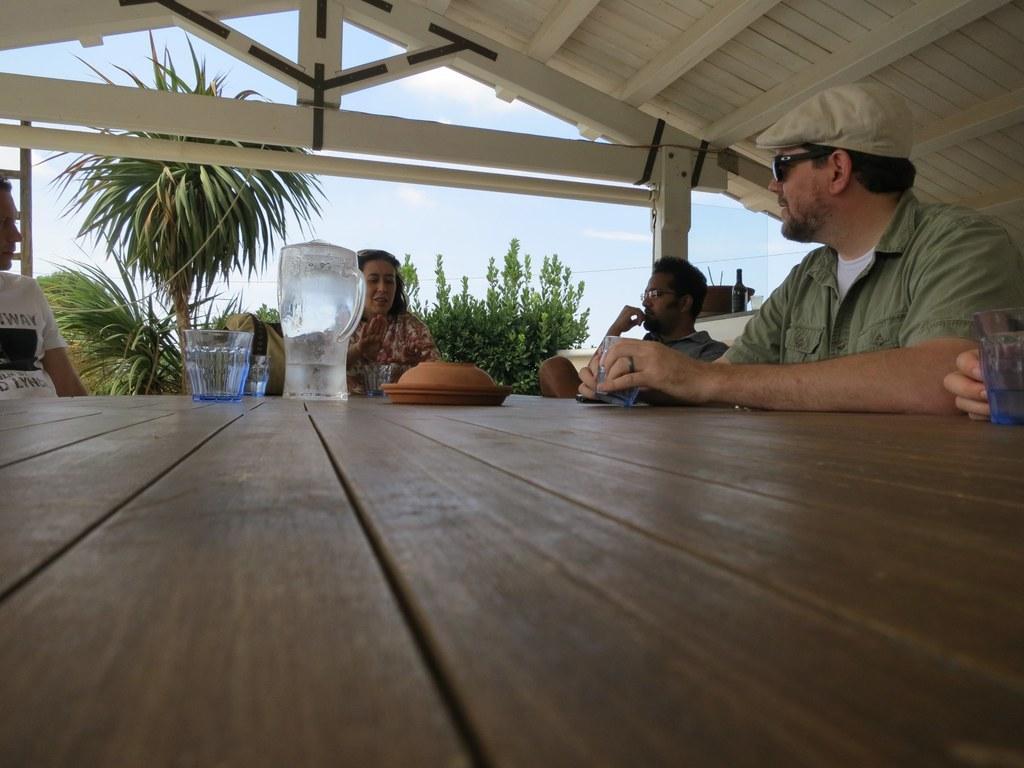In one or two sentences, can you explain what this image depicts? In this image we can see a few people sitting, among them, some are wearing the spectacles, in front of them, there is a table, on the table, we can see the glasses, jug and some objects, also we can see the trees, bottle, bowl, glass and a ladder, in the background we can see the sky with clouds. 